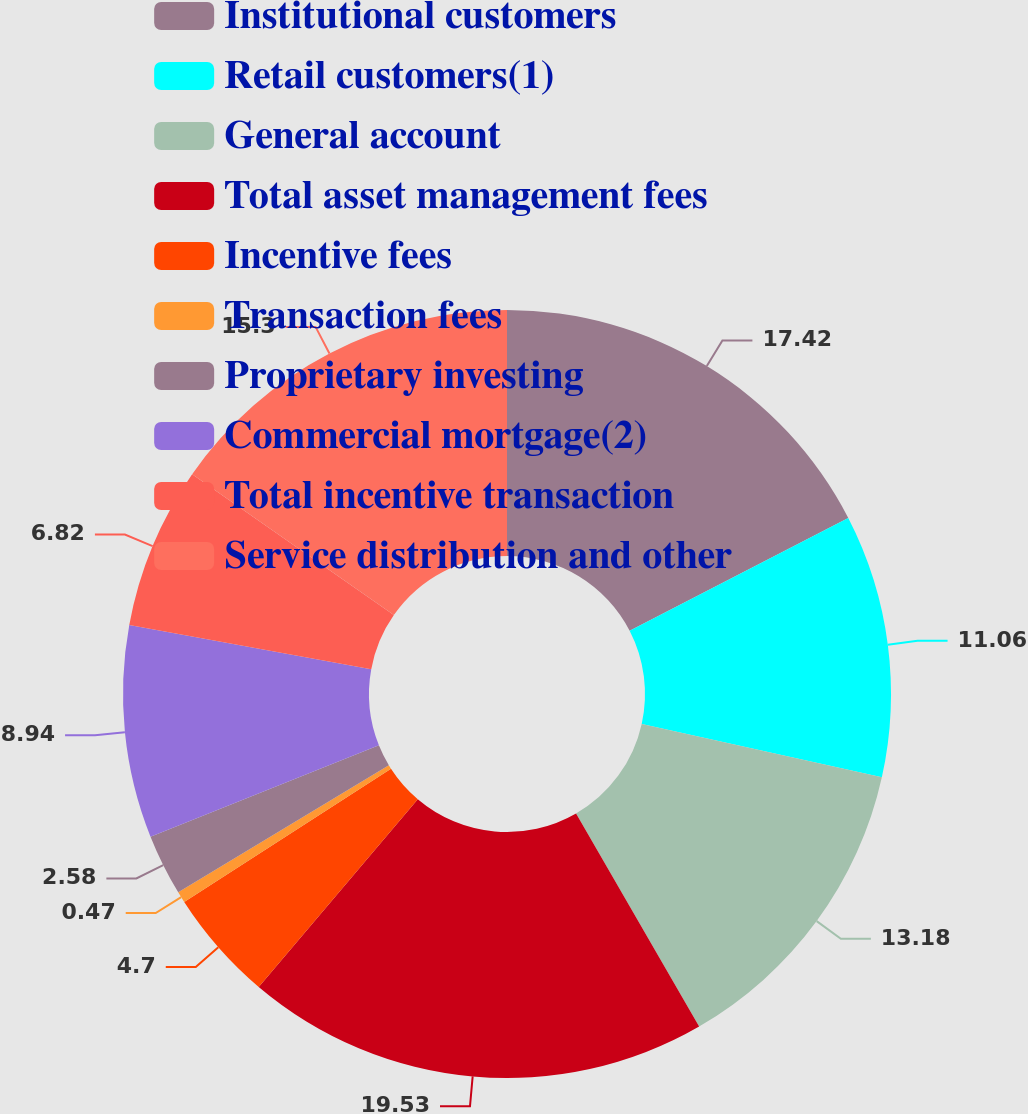Convert chart to OTSL. <chart><loc_0><loc_0><loc_500><loc_500><pie_chart><fcel>Institutional customers<fcel>Retail customers(1)<fcel>General account<fcel>Total asset management fees<fcel>Incentive fees<fcel>Transaction fees<fcel>Proprietary investing<fcel>Commercial mortgage(2)<fcel>Total incentive transaction<fcel>Service distribution and other<nl><fcel>17.42%<fcel>11.06%<fcel>13.18%<fcel>19.53%<fcel>4.7%<fcel>0.47%<fcel>2.58%<fcel>8.94%<fcel>6.82%<fcel>15.3%<nl></chart> 